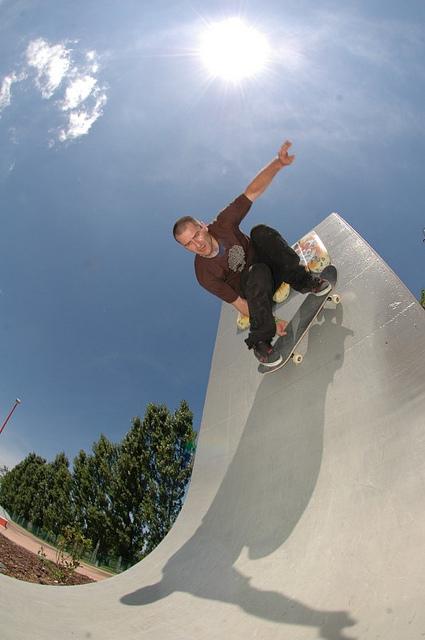Is the sun partly covered by clouds?
Write a very short answer. No. Will the man fall?
Short answer required. No. Is he upside down?
Keep it brief. No. 